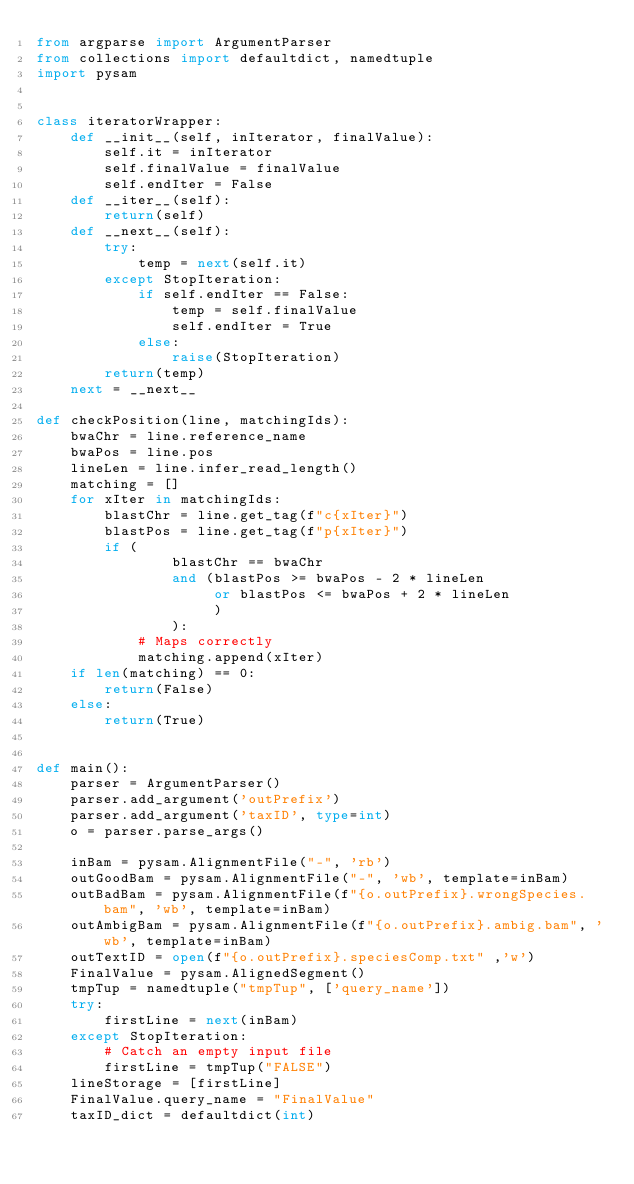Convert code to text. <code><loc_0><loc_0><loc_500><loc_500><_Python_>from argparse import ArgumentParser
from collections import defaultdict, namedtuple
import pysam


class iteratorWrapper:
    def __init__(self, inIterator, finalValue):
        self.it = inIterator
        self.finalValue = finalValue
        self.endIter = False
    def __iter__(self):
        return(self)
    def __next__(self):
        try:
            temp = next(self.it)
        except StopIteration:
            if self.endIter == False:
                temp = self.finalValue
                self.endIter = True
            else:
                raise(StopIteration)
        return(temp)
    next = __next__

def checkPosition(line, matchingIds):
    bwaChr = line.reference_name
    bwaPos = line.pos
    lineLen = line.infer_read_length()
    matching = []
    for xIter in matchingIds:
        blastChr = line.get_tag(f"c{xIter}")
        blastPos = line.get_tag(f"p{xIter}")
        if (
                blastChr == bwaChr 
                and (blastPos >= bwaPos - 2 * lineLen 
                     or blastPos <= bwaPos + 2 * lineLen
                     )
                ):
            # Maps correctly
            matching.append(xIter)
    if len(matching) == 0:
        return(False)
    else:
        return(True)
    

def main():
    parser = ArgumentParser()
    parser.add_argument('outPrefix')
    parser.add_argument('taxID', type=int)
    o = parser.parse_args()
    
    inBam = pysam.AlignmentFile("-", 'rb')
    outGoodBam = pysam.AlignmentFile("-", 'wb', template=inBam)
    outBadBam = pysam.AlignmentFile(f"{o.outPrefix}.wrongSpecies.bam", 'wb', template=inBam)
    outAmbigBam = pysam.AlignmentFile(f"{o.outPrefix}.ambig.bam", 'wb', template=inBam)
    outTextID = open(f"{o.outPrefix}.speciesComp.txt" ,'w')
    FinalValue = pysam.AlignedSegment()
    tmpTup = namedtuple("tmpTup", ['query_name'])
    try:
        firstLine = next(inBam)
    except StopIteration:
        # Catch an empty input file
        firstLine = tmpTup("FALSE")
    lineStorage = [firstLine]
    FinalValue.query_name = "FinalValue"
    taxID_dict = defaultdict(int)</code> 